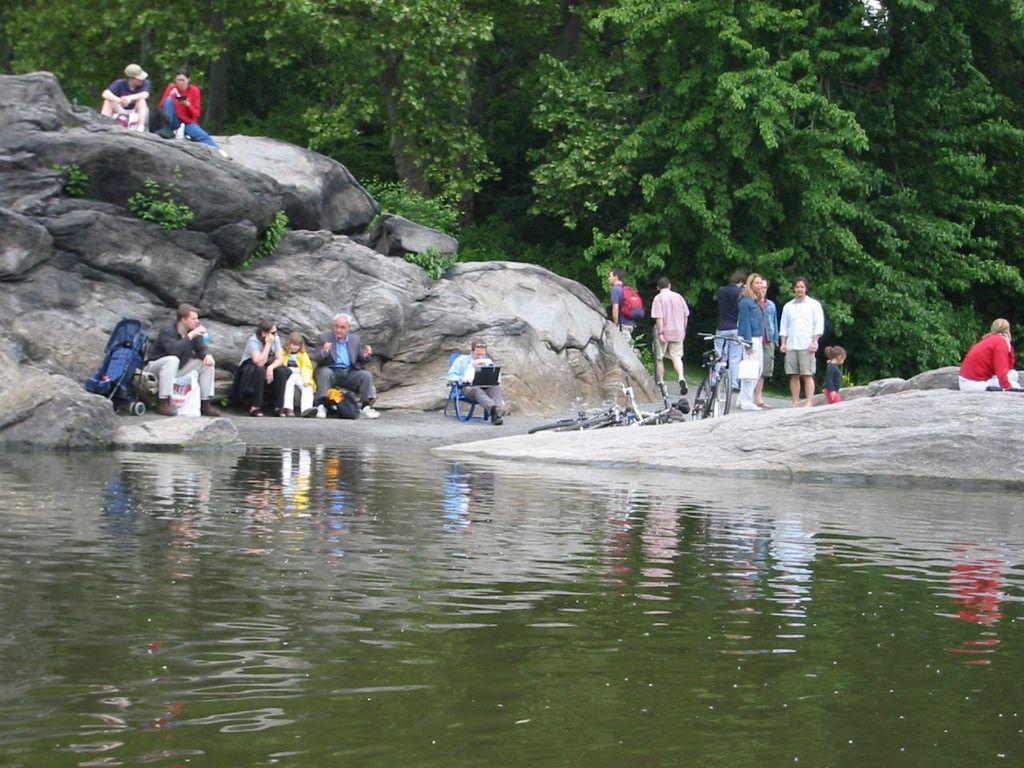Could you give a brief overview of what you see in this image? In this picture we can see the water, rocks, plants, some people, bicycles, stroller, bags, some objects and a man sitting on a chair. In the background we can see trees. 